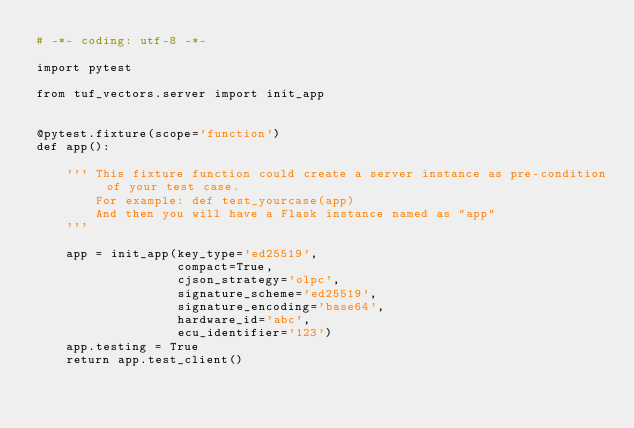<code> <loc_0><loc_0><loc_500><loc_500><_Python_># -*- coding: utf-8 -*-

import pytest

from tuf_vectors.server import init_app


@pytest.fixture(scope='function')
def app():

    ''' This fixture function could create a server instance as pre-condition of your test case.
        For example: def test_yourcase(app)
        And then you will have a Flask instance named as "app"
    '''

    app = init_app(key_type='ed25519',
                   compact=True,
                   cjson_strategy='olpc',
                   signature_scheme='ed25519',
                   signature_encoding='base64',
                   hardware_id='abc',
                   ecu_identifier='123')
    app.testing = True
    return app.test_client()
</code> 